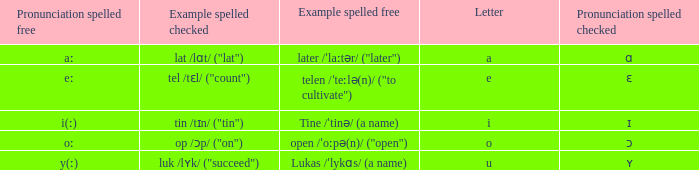What is Pronunciation Spelled Free, when Pronunciation Spelled Checked is "ɑ"? Aː. 